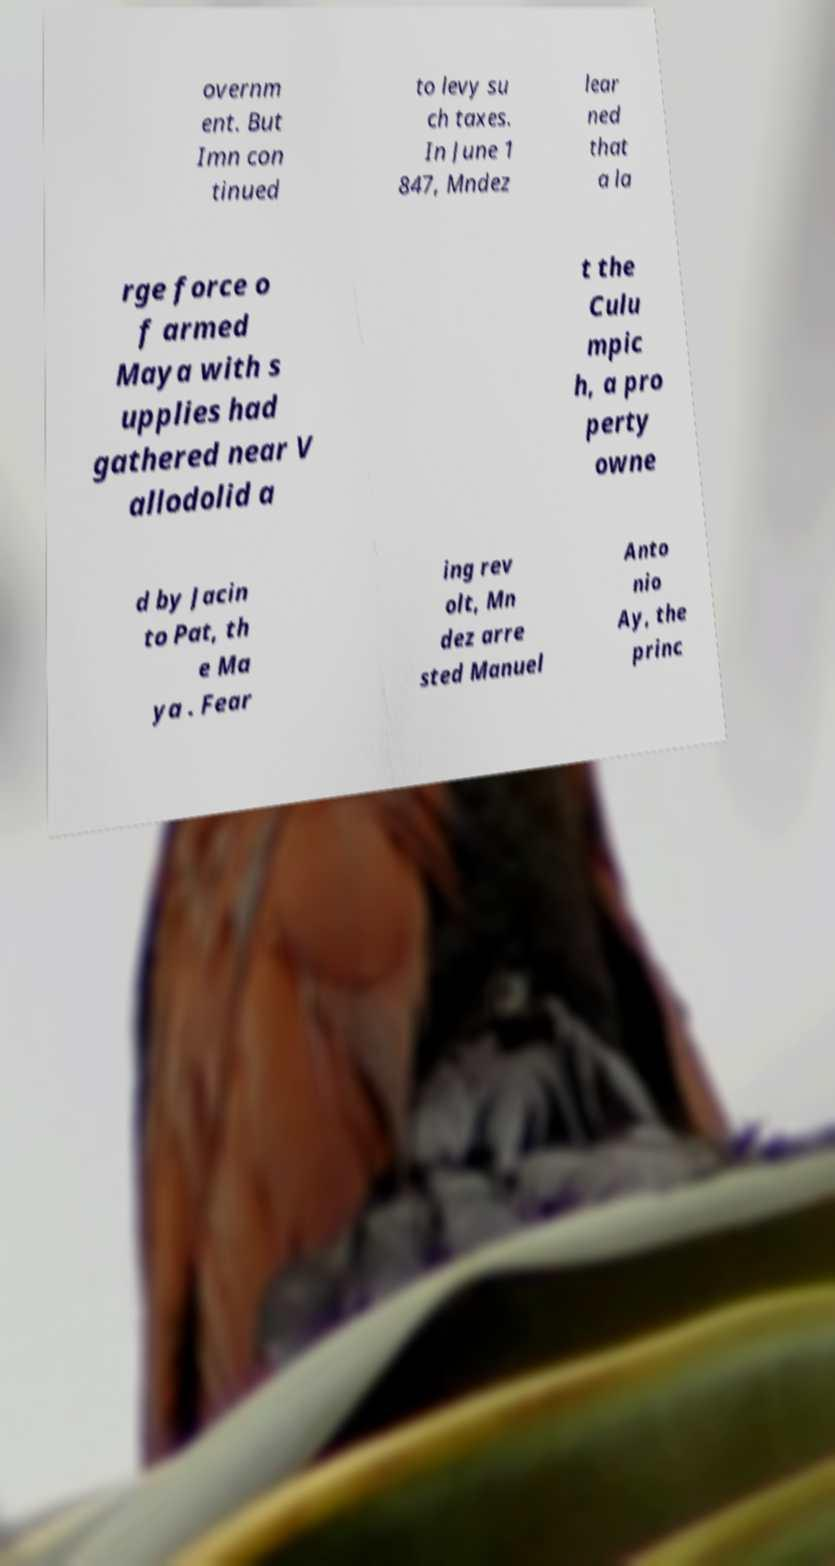Please identify and transcribe the text found in this image. overnm ent. But Imn con tinued to levy su ch taxes. In June 1 847, Mndez lear ned that a la rge force o f armed Maya with s upplies had gathered near V allodolid a t the Culu mpic h, a pro perty owne d by Jacin to Pat, th e Ma ya . Fear ing rev olt, Mn dez arre sted Manuel Anto nio Ay, the princ 